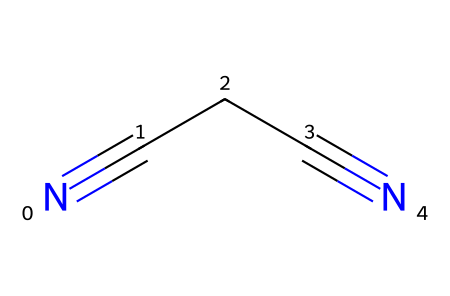What is the common name of the compound represented by the SMILES? The SMILES representation shows a compound with two cyano groups connected by a two-carbon chain, which is known as succinonitrile.
Answer: succinonitrile How many carbon atoms are present in the structure? The SMILES notation indicates two carbon atoms in the central chain (N#C-C#N), as the cyano groups (N#C) do not contribute additional carbon atoms to the count.
Answer: 2 What types of functional groups are present in succinonitrile? The structure contains cyano groups (-C≡N); these are characterized by a carbon triple-bonded to a nitrogen atom, making them the primary functional group in this compound.
Answer: cyano groups What is the total number of nitrogen atoms in succinonitrile? There are two nitrogen atoms in the cyano groups connected to each carbon of the chain (N#C and C#N), resulting in a total of two nitrogen atoms in the molecule.
Answer: 2 Is this compound more polar or non-polar based on its structure? The presence of the polar cyano groups, characterized by the C≡N bond, influences the overall polarity of the molecule, making it more polar rather than non-polar.
Answer: polar What type of chemical reaction could succinonitrile be involved in during rubber vulcanization? During rubber vulcanization, succinonitrile acts as a cross-linking agent, forming bonds with other molecules to enhance the properties of rubber, a common type of reaction in this context.
Answer: cross-linking agent 